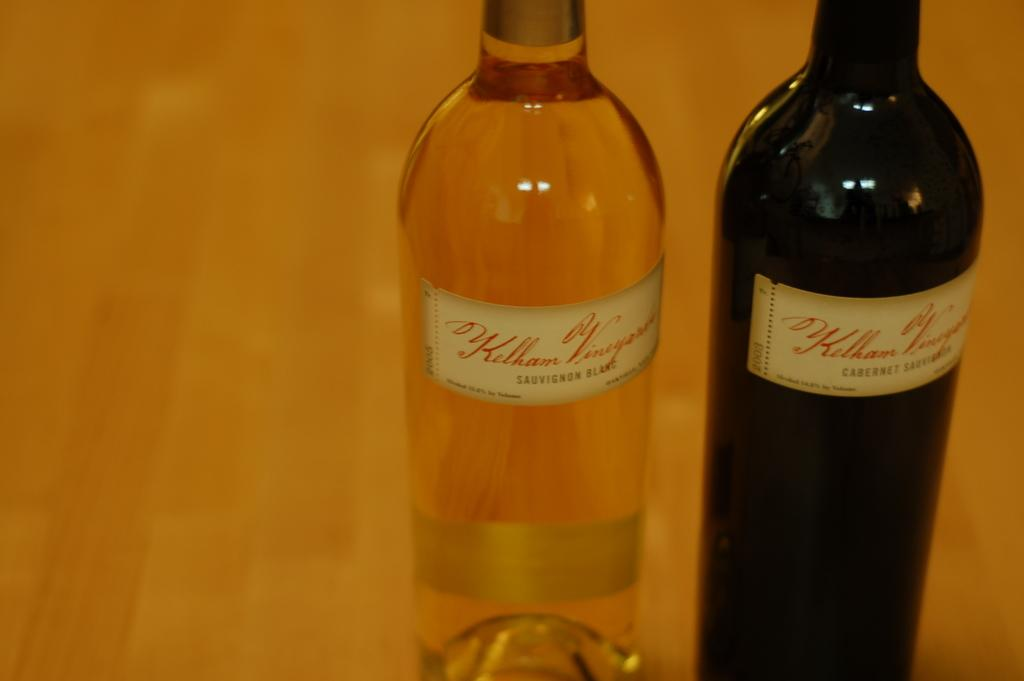How many bottles can be seen in the image? There are two bottles in the image. Where are the bottles located? The bottles are on a table. Is there a spy joining the conversation in the image? There is no indication of a spy or any conversation in the image; it only shows two bottles on a table. 